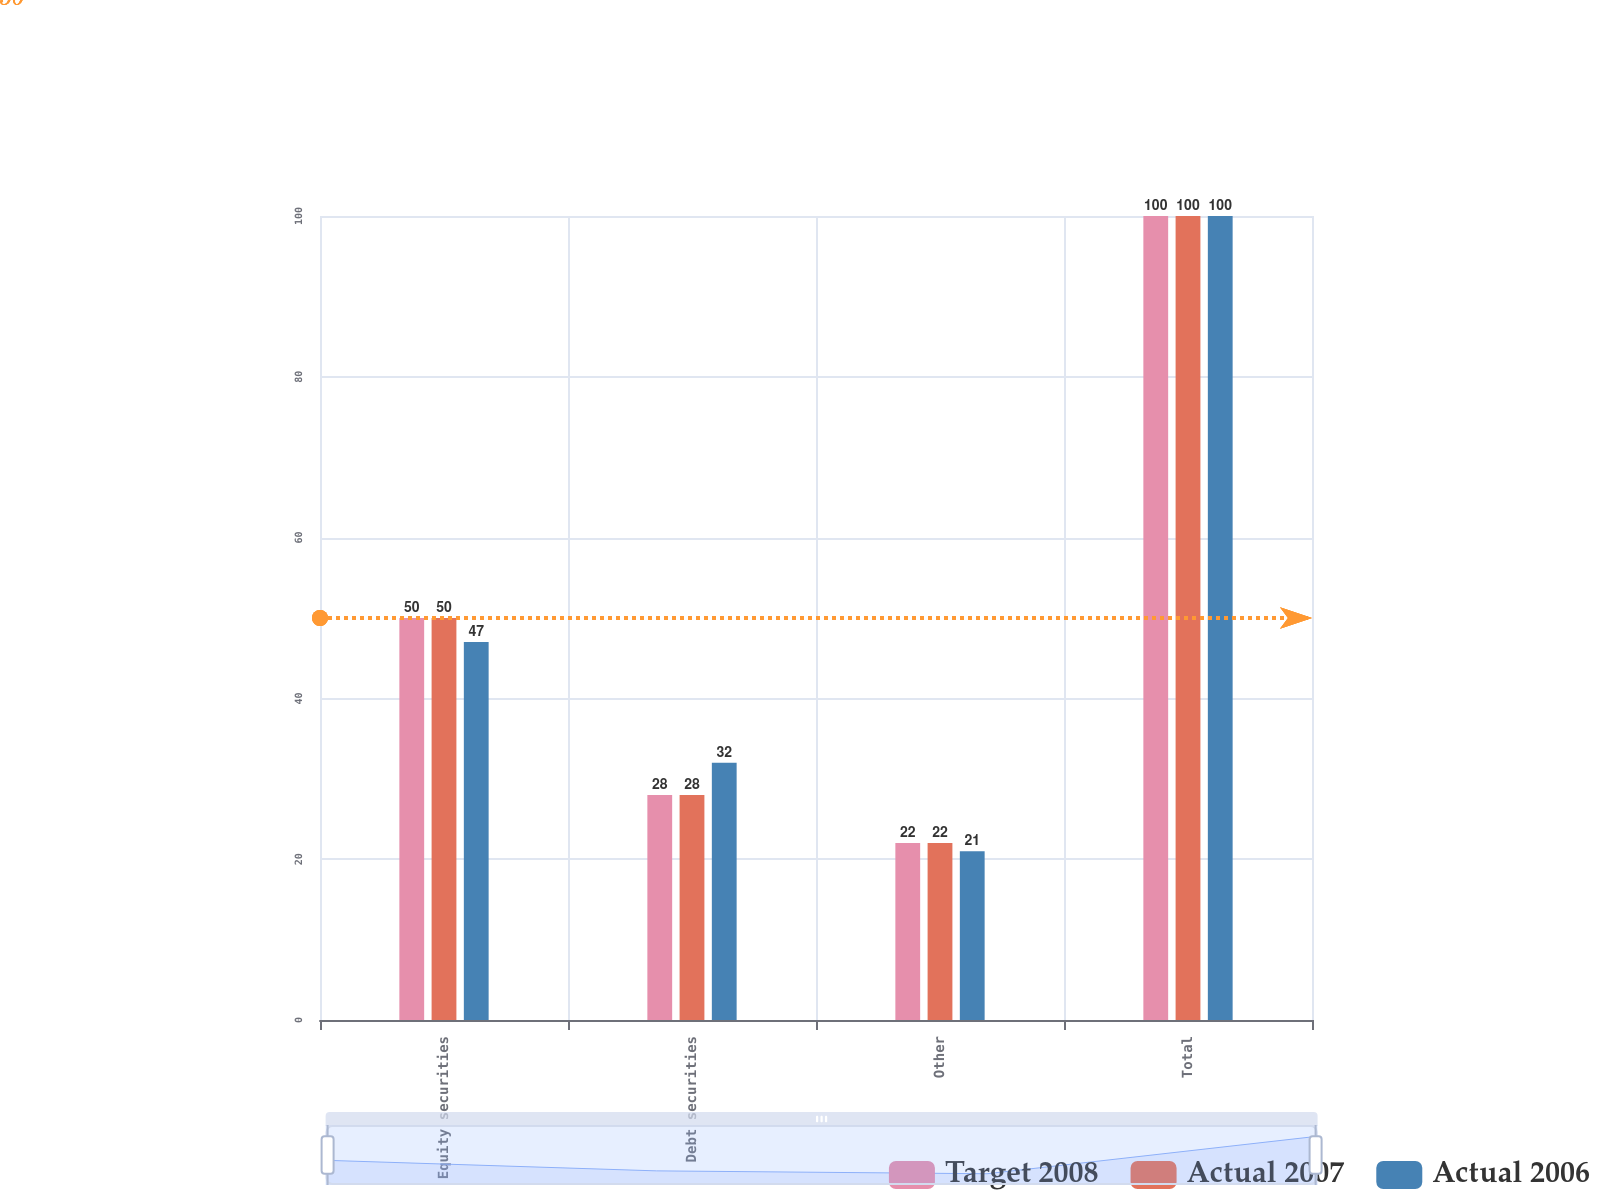<chart> <loc_0><loc_0><loc_500><loc_500><stacked_bar_chart><ecel><fcel>Equity securities<fcel>Debt securities<fcel>Other<fcel>Total<nl><fcel>Target 2008<fcel>50<fcel>28<fcel>22<fcel>100<nl><fcel>Actual 2007<fcel>50<fcel>28<fcel>22<fcel>100<nl><fcel>Actual 2006<fcel>47<fcel>32<fcel>21<fcel>100<nl></chart> 